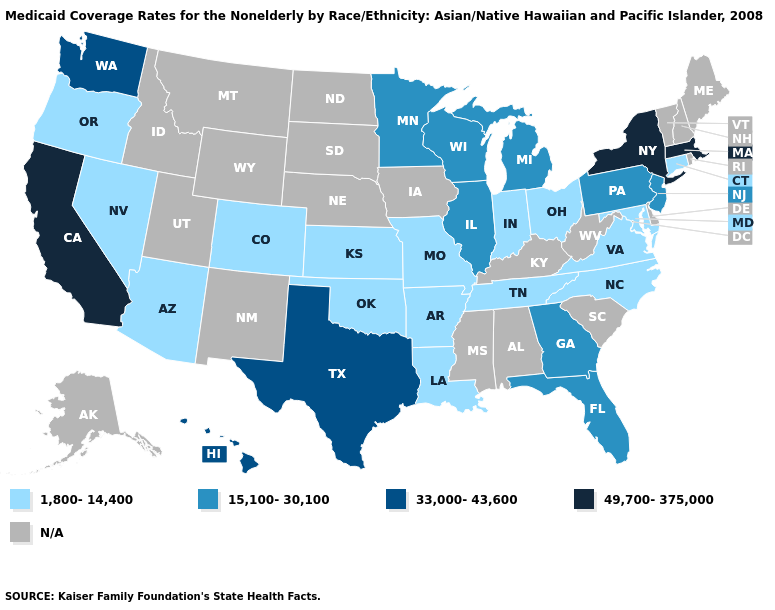Name the states that have a value in the range N/A?
Quick response, please. Alabama, Alaska, Delaware, Idaho, Iowa, Kentucky, Maine, Mississippi, Montana, Nebraska, New Hampshire, New Mexico, North Dakota, Rhode Island, South Carolina, South Dakota, Utah, Vermont, West Virginia, Wyoming. Name the states that have a value in the range 33,000-43,600?
Answer briefly. Hawaii, Texas, Washington. Name the states that have a value in the range 15,100-30,100?
Short answer required. Florida, Georgia, Illinois, Michigan, Minnesota, New Jersey, Pennsylvania, Wisconsin. Name the states that have a value in the range 49,700-375,000?
Quick response, please. California, Massachusetts, New York. Does Georgia have the lowest value in the USA?
Write a very short answer. No. What is the value of Georgia?
Give a very brief answer. 15,100-30,100. Name the states that have a value in the range 15,100-30,100?
Quick response, please. Florida, Georgia, Illinois, Michigan, Minnesota, New Jersey, Pennsylvania, Wisconsin. Does Ohio have the highest value in the MidWest?
Write a very short answer. No. Which states have the lowest value in the USA?
Keep it brief. Arizona, Arkansas, Colorado, Connecticut, Indiana, Kansas, Louisiana, Maryland, Missouri, Nevada, North Carolina, Ohio, Oklahoma, Oregon, Tennessee, Virginia. Does Tennessee have the lowest value in the South?
Keep it brief. Yes. What is the highest value in states that border West Virginia?
Quick response, please. 15,100-30,100. Name the states that have a value in the range N/A?
Concise answer only. Alabama, Alaska, Delaware, Idaho, Iowa, Kentucky, Maine, Mississippi, Montana, Nebraska, New Hampshire, New Mexico, North Dakota, Rhode Island, South Carolina, South Dakota, Utah, Vermont, West Virginia, Wyoming. Does Pennsylvania have the highest value in the Northeast?
Give a very brief answer. No. Does North Carolina have the lowest value in the South?
Give a very brief answer. Yes. 